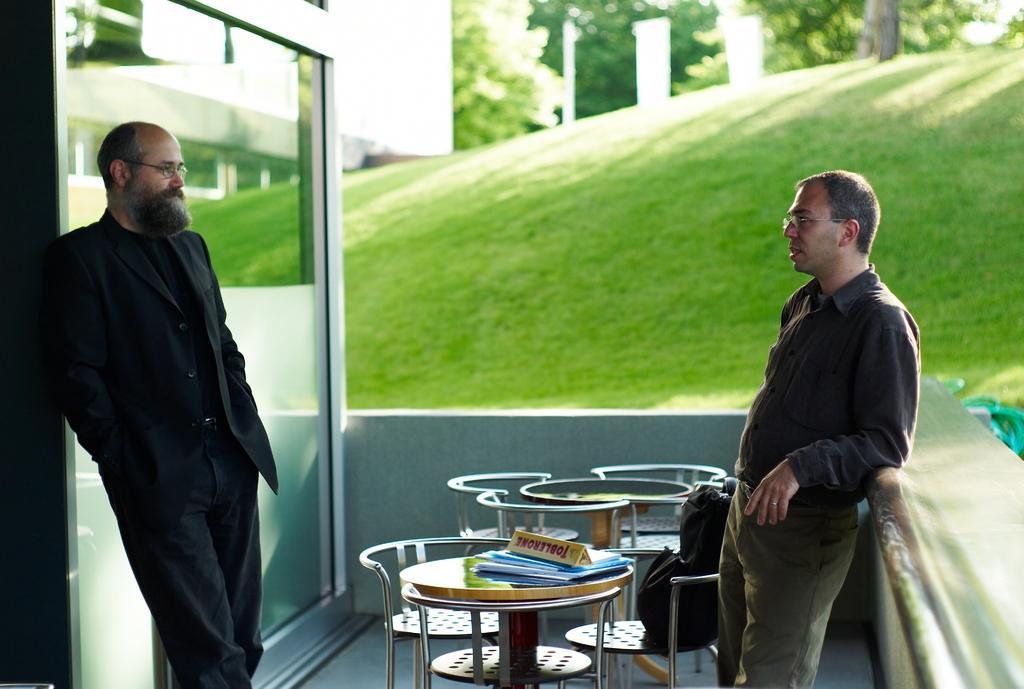How would you summarize this image in a sentence or two? 2 people are standing talking to each other. in the center there is a table and chairs, on which there is a chocolate. behind him there are grass and trees. 